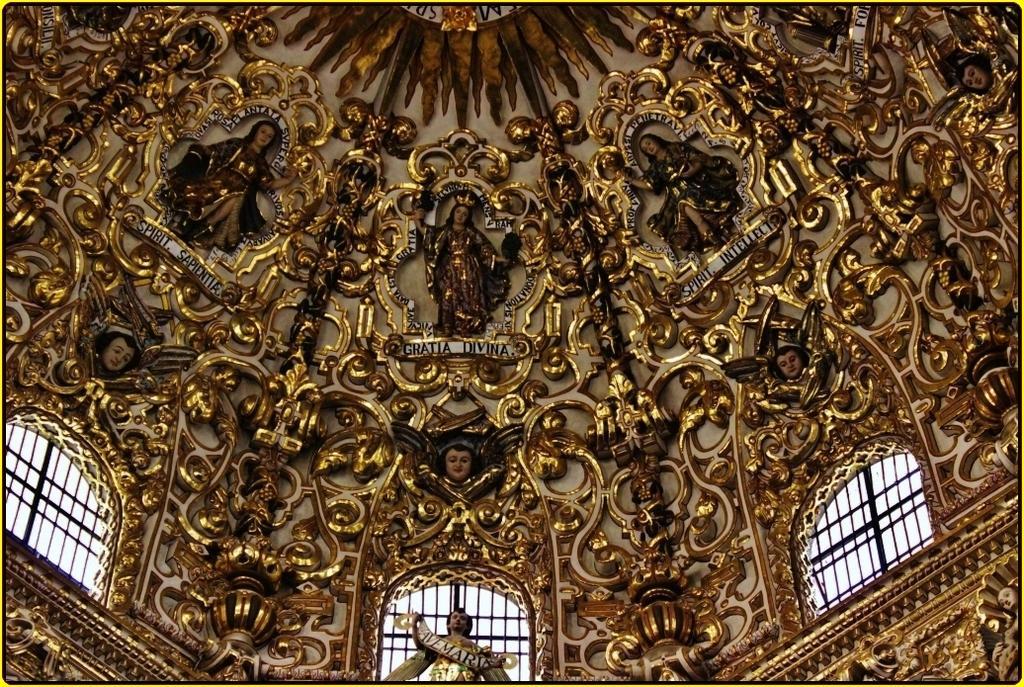How would you summarize this image in a sentence or two? This picture is taken inside the building. In this image, in the middle, we can see a sculpture. On the right side and left side, we can see a grill window. At the top, we can see some sculptures and a roof. 